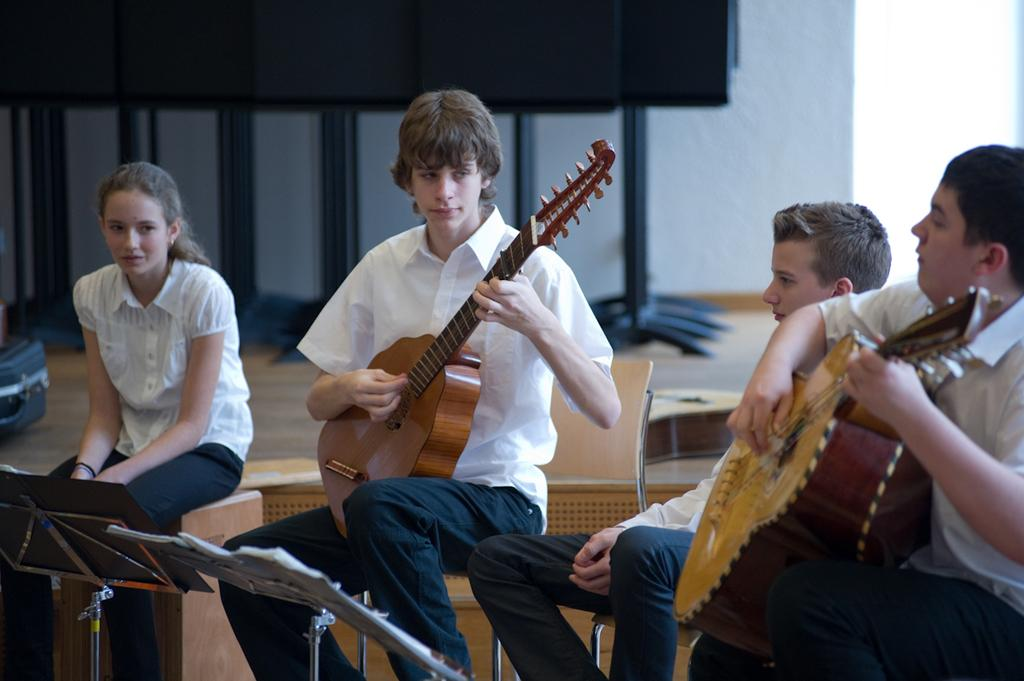How many people are in the image? There are four persons in the image. What are the persons doing in the image? They are sitting on chairs and playing guitar. What can be seen in the background of the image? There is a wall in the background of the image. What is the surface they are sitting on? The image shows a floor. Are there any objects related to learning or reading in the image? Yes, there are books in the image. How many sheep can be seen in the image? There are no sheep present in the image. What type of cub is sitting next to the guitar player? There is no cub present in the image. 